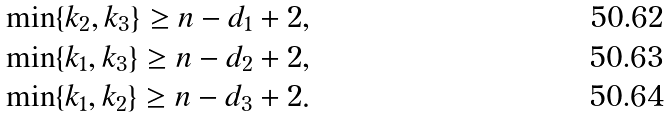Convert formula to latex. <formula><loc_0><loc_0><loc_500><loc_500>& \min \{ k _ { 2 } , k _ { 3 } \} \geq n - d _ { 1 } + 2 , \\ & \min \{ k _ { 1 } , k _ { 3 } \} \geq n - d _ { 2 } + 2 , \\ & \min \{ k _ { 1 } , k _ { 2 } \} \geq n - d _ { 3 } + 2 .</formula> 